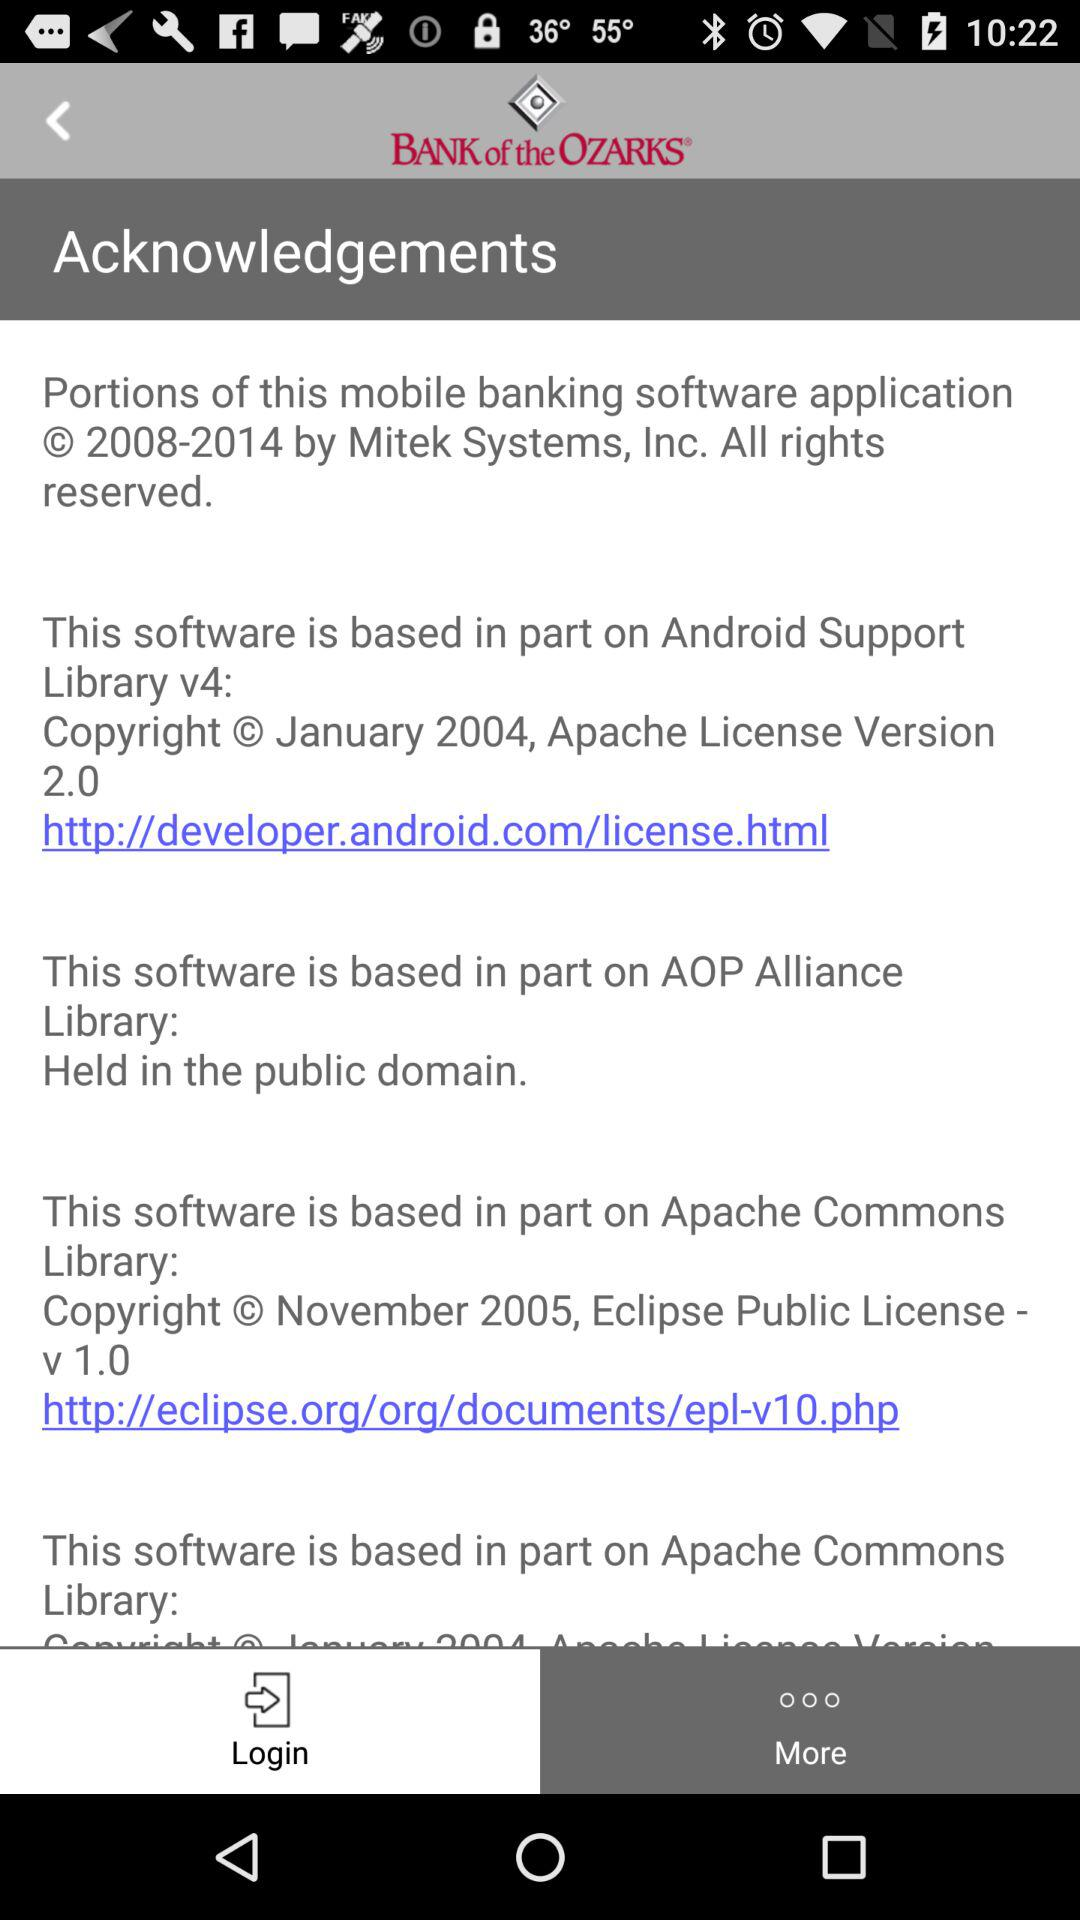What is the application name? The application name is "BANK of the OZARKS®". 